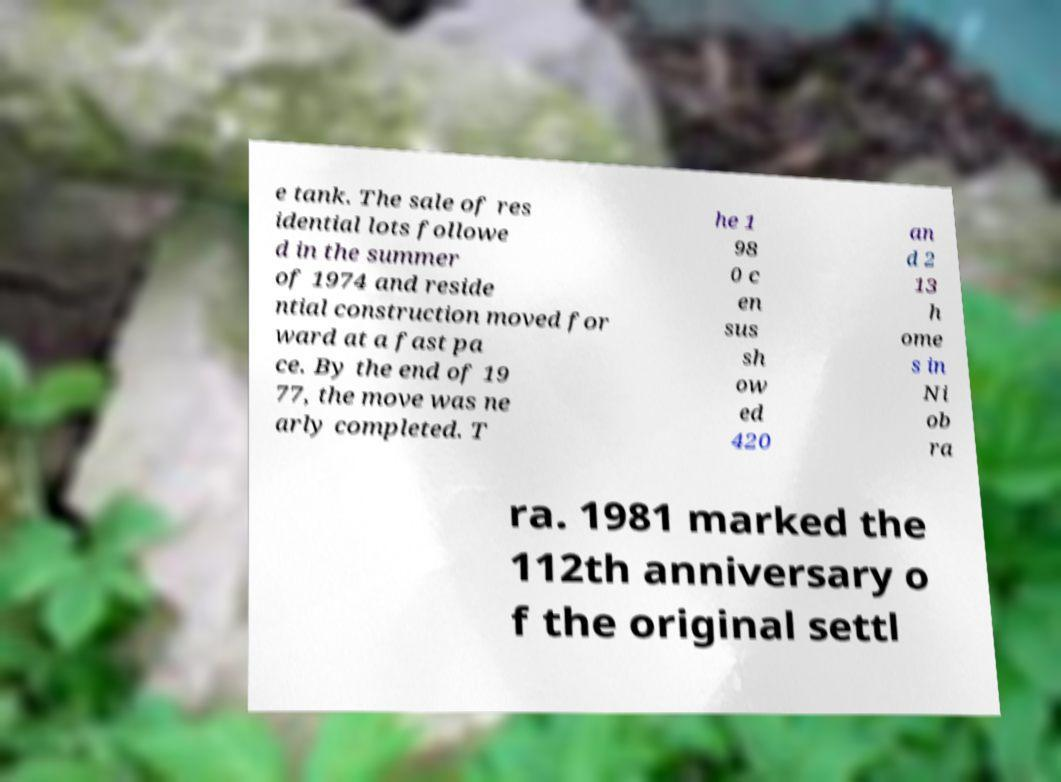Can you accurately transcribe the text from the provided image for me? e tank. The sale of res idential lots followe d in the summer of 1974 and reside ntial construction moved for ward at a fast pa ce. By the end of 19 77, the move was ne arly completed. T he 1 98 0 c en sus sh ow ed 420 an d 2 13 h ome s in Ni ob ra ra. 1981 marked the 112th anniversary o f the original settl 